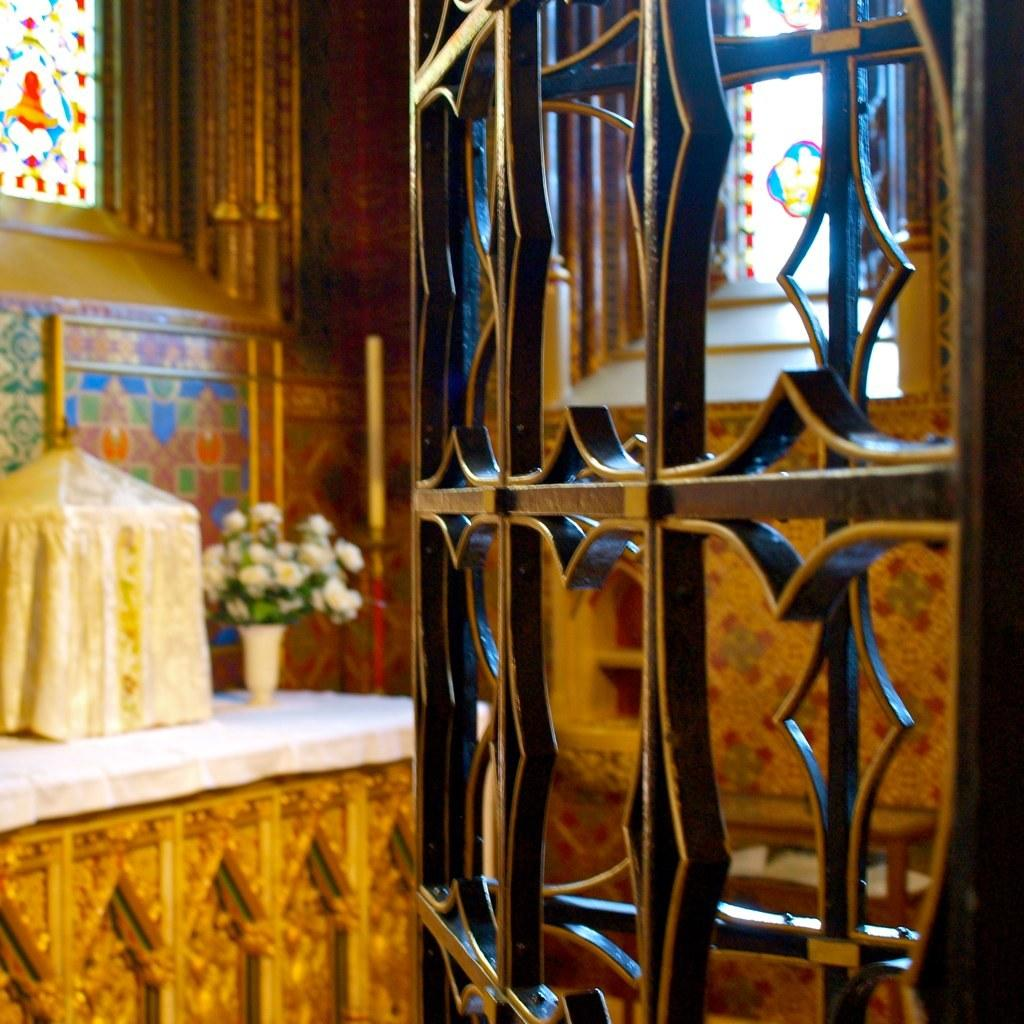What type of structure is present in the image? There is an iron frame in the image. What can be seen in the background of the image? There is a table in the background of the image. What is on the table in the image? There is a flower vase and a box on the table. What is the wall made of in the image? There is a wall in the image, and it has glass windows. What type of bottle is on the table in the image? There is no bottle present on the table in the image. Is there a baby sitting on the iron frame in the image? There is no baby present in the image. 